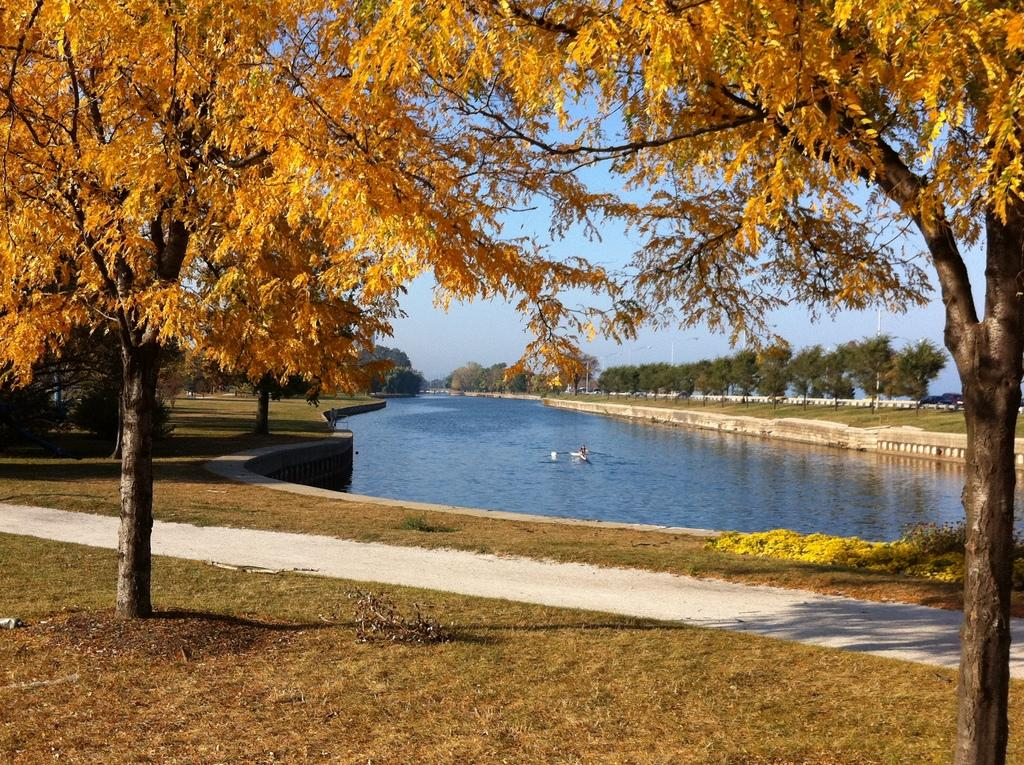What body of water is visible in the image? There is a lake in the image. What type of vegetation surrounds the lake? Trees are present around the lake. What type of land is visible around the lake? Grasslands are visible around the lake. What can be seen in the background of the image? The sky is visible in the background of the image. What type of food is being prepared on the edge of the lake? There is no food or preparation visible in the image. 